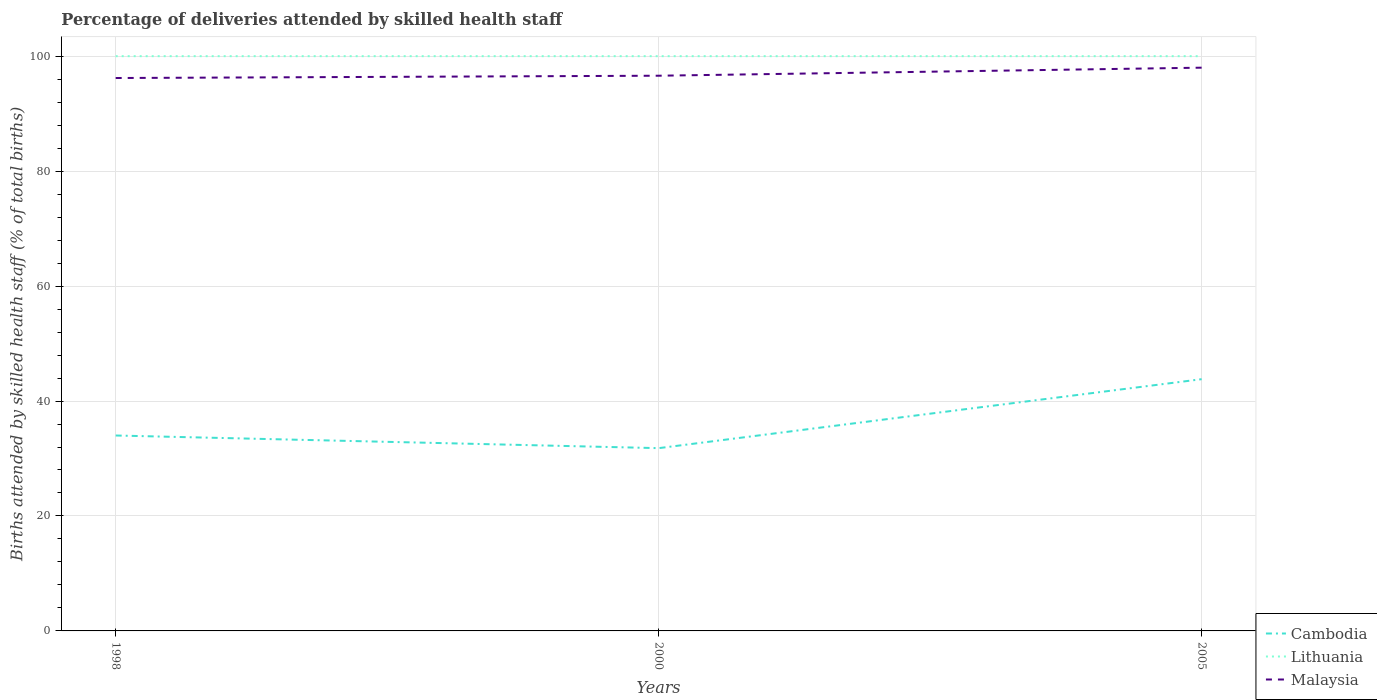Across all years, what is the maximum percentage of births attended by skilled health staff in Cambodia?
Provide a short and direct response. 31.8. What is the total percentage of births attended by skilled health staff in Cambodia in the graph?
Your response must be concise. -9.8. What is the difference between the highest and the second highest percentage of births attended by skilled health staff in Malaysia?
Your answer should be very brief. 1.8. What is the difference between the highest and the lowest percentage of births attended by skilled health staff in Lithuania?
Your answer should be very brief. 0. How many lines are there?
Your answer should be compact. 3. What is the difference between two consecutive major ticks on the Y-axis?
Your response must be concise. 20. How many legend labels are there?
Give a very brief answer. 3. How are the legend labels stacked?
Your response must be concise. Vertical. What is the title of the graph?
Make the answer very short. Percentage of deliveries attended by skilled health staff. What is the label or title of the X-axis?
Make the answer very short. Years. What is the label or title of the Y-axis?
Your answer should be very brief. Births attended by skilled health staff (% of total births). What is the Births attended by skilled health staff (% of total births) of Cambodia in 1998?
Your answer should be very brief. 34. What is the Births attended by skilled health staff (% of total births) of Lithuania in 1998?
Your response must be concise. 100. What is the Births attended by skilled health staff (% of total births) in Malaysia in 1998?
Provide a short and direct response. 96.2. What is the Births attended by skilled health staff (% of total births) of Cambodia in 2000?
Your answer should be very brief. 31.8. What is the Births attended by skilled health staff (% of total births) of Lithuania in 2000?
Offer a terse response. 100. What is the Births attended by skilled health staff (% of total births) in Malaysia in 2000?
Offer a very short reply. 96.6. What is the Births attended by skilled health staff (% of total births) in Cambodia in 2005?
Keep it short and to the point. 43.8. What is the Births attended by skilled health staff (% of total births) of Malaysia in 2005?
Provide a succinct answer. 98. Across all years, what is the maximum Births attended by skilled health staff (% of total births) of Cambodia?
Your answer should be compact. 43.8. Across all years, what is the maximum Births attended by skilled health staff (% of total births) of Lithuania?
Offer a terse response. 100. Across all years, what is the maximum Births attended by skilled health staff (% of total births) in Malaysia?
Your response must be concise. 98. Across all years, what is the minimum Births attended by skilled health staff (% of total births) of Cambodia?
Your response must be concise. 31.8. Across all years, what is the minimum Births attended by skilled health staff (% of total births) in Lithuania?
Ensure brevity in your answer.  100. Across all years, what is the minimum Births attended by skilled health staff (% of total births) in Malaysia?
Make the answer very short. 96.2. What is the total Births attended by skilled health staff (% of total births) of Cambodia in the graph?
Give a very brief answer. 109.6. What is the total Births attended by skilled health staff (% of total births) of Lithuania in the graph?
Provide a short and direct response. 300. What is the total Births attended by skilled health staff (% of total births) in Malaysia in the graph?
Provide a short and direct response. 290.8. What is the difference between the Births attended by skilled health staff (% of total births) of Lithuania in 1998 and that in 2000?
Your response must be concise. 0. What is the difference between the Births attended by skilled health staff (% of total births) of Malaysia in 1998 and that in 2000?
Keep it short and to the point. -0.4. What is the difference between the Births attended by skilled health staff (% of total births) of Lithuania in 1998 and that in 2005?
Provide a succinct answer. 0. What is the difference between the Births attended by skilled health staff (% of total births) of Malaysia in 1998 and that in 2005?
Your response must be concise. -1.8. What is the difference between the Births attended by skilled health staff (% of total births) of Cambodia in 2000 and that in 2005?
Provide a succinct answer. -12. What is the difference between the Births attended by skilled health staff (% of total births) of Malaysia in 2000 and that in 2005?
Make the answer very short. -1.4. What is the difference between the Births attended by skilled health staff (% of total births) in Cambodia in 1998 and the Births attended by skilled health staff (% of total births) in Lithuania in 2000?
Keep it short and to the point. -66. What is the difference between the Births attended by skilled health staff (% of total births) of Cambodia in 1998 and the Births attended by skilled health staff (% of total births) of Malaysia in 2000?
Offer a very short reply. -62.6. What is the difference between the Births attended by skilled health staff (% of total births) in Lithuania in 1998 and the Births attended by skilled health staff (% of total births) in Malaysia in 2000?
Offer a very short reply. 3.4. What is the difference between the Births attended by skilled health staff (% of total births) in Cambodia in 1998 and the Births attended by skilled health staff (% of total births) in Lithuania in 2005?
Offer a very short reply. -66. What is the difference between the Births attended by skilled health staff (% of total births) in Cambodia in 1998 and the Births attended by skilled health staff (% of total births) in Malaysia in 2005?
Your answer should be compact. -64. What is the difference between the Births attended by skilled health staff (% of total births) in Cambodia in 2000 and the Births attended by skilled health staff (% of total births) in Lithuania in 2005?
Give a very brief answer. -68.2. What is the difference between the Births attended by skilled health staff (% of total births) in Cambodia in 2000 and the Births attended by skilled health staff (% of total births) in Malaysia in 2005?
Keep it short and to the point. -66.2. What is the difference between the Births attended by skilled health staff (% of total births) of Lithuania in 2000 and the Births attended by skilled health staff (% of total births) of Malaysia in 2005?
Offer a very short reply. 2. What is the average Births attended by skilled health staff (% of total births) of Cambodia per year?
Your answer should be compact. 36.53. What is the average Births attended by skilled health staff (% of total births) in Lithuania per year?
Ensure brevity in your answer.  100. What is the average Births attended by skilled health staff (% of total births) of Malaysia per year?
Your answer should be compact. 96.93. In the year 1998, what is the difference between the Births attended by skilled health staff (% of total births) of Cambodia and Births attended by skilled health staff (% of total births) of Lithuania?
Provide a short and direct response. -66. In the year 1998, what is the difference between the Births attended by skilled health staff (% of total births) in Cambodia and Births attended by skilled health staff (% of total births) in Malaysia?
Keep it short and to the point. -62.2. In the year 2000, what is the difference between the Births attended by skilled health staff (% of total births) of Cambodia and Births attended by skilled health staff (% of total births) of Lithuania?
Your response must be concise. -68.2. In the year 2000, what is the difference between the Births attended by skilled health staff (% of total births) in Cambodia and Births attended by skilled health staff (% of total births) in Malaysia?
Offer a terse response. -64.8. In the year 2000, what is the difference between the Births attended by skilled health staff (% of total births) in Lithuania and Births attended by skilled health staff (% of total births) in Malaysia?
Provide a succinct answer. 3.4. In the year 2005, what is the difference between the Births attended by skilled health staff (% of total births) of Cambodia and Births attended by skilled health staff (% of total births) of Lithuania?
Your response must be concise. -56.2. In the year 2005, what is the difference between the Births attended by skilled health staff (% of total births) in Cambodia and Births attended by skilled health staff (% of total births) in Malaysia?
Keep it short and to the point. -54.2. In the year 2005, what is the difference between the Births attended by skilled health staff (% of total births) in Lithuania and Births attended by skilled health staff (% of total births) in Malaysia?
Keep it short and to the point. 2. What is the ratio of the Births attended by skilled health staff (% of total births) in Cambodia in 1998 to that in 2000?
Make the answer very short. 1.07. What is the ratio of the Births attended by skilled health staff (% of total births) in Lithuania in 1998 to that in 2000?
Ensure brevity in your answer.  1. What is the ratio of the Births attended by skilled health staff (% of total births) in Cambodia in 1998 to that in 2005?
Your answer should be compact. 0.78. What is the ratio of the Births attended by skilled health staff (% of total births) in Malaysia in 1998 to that in 2005?
Make the answer very short. 0.98. What is the ratio of the Births attended by skilled health staff (% of total births) of Cambodia in 2000 to that in 2005?
Offer a terse response. 0.73. What is the ratio of the Births attended by skilled health staff (% of total births) in Lithuania in 2000 to that in 2005?
Offer a terse response. 1. What is the ratio of the Births attended by skilled health staff (% of total births) in Malaysia in 2000 to that in 2005?
Your response must be concise. 0.99. What is the difference between the highest and the second highest Births attended by skilled health staff (% of total births) in Malaysia?
Make the answer very short. 1.4. What is the difference between the highest and the lowest Births attended by skilled health staff (% of total births) of Malaysia?
Provide a short and direct response. 1.8. 